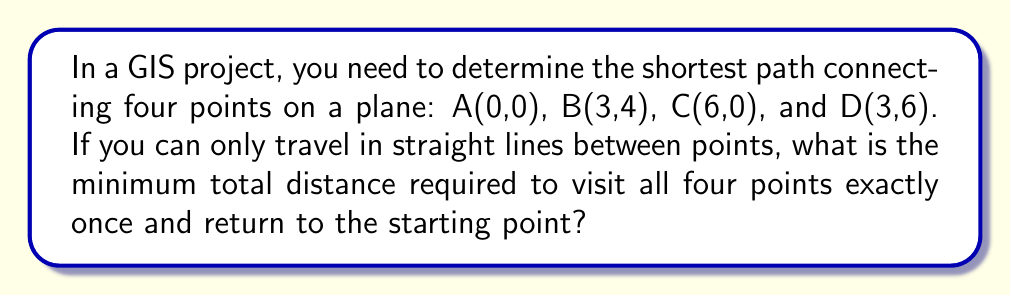Teach me how to tackle this problem. To solve this problem, we need to consider all possible paths and calculate their lengths. The approach is as follows:

1) First, list all possible paths:
   ABCDA, ABDCA, ACBDA, ACDBA, ADBCA, ADCBA

2) For each path, calculate the total distance using the distance formula:
   $d = \sqrt{(x_2-x_1)^2 + (y_2-y_1)^2}$

3) Let's calculate the distances between each pair of points:
   AB = $\sqrt{3^2 + 4^2} = 5$
   AC = $\sqrt{6^2 + 0^2} = 6$
   AD = $\sqrt{3^2 + 6^2} = 3\sqrt{5}$
   BC = $\sqrt{3^2 + (-4)^2} = 5$
   BD = $\sqrt{0^2 + 2^2} = 2$
   CD = $\sqrt{3^2 + 6^2} = 3\sqrt{5}$

4) Now, calculate the total distance for each path:
   ABCDA: $5 + 5 + 3\sqrt{5} + 6 = 16 + 3\sqrt{5}$
   ABDCA: $5 + 2 + 3\sqrt{5} + 6 = 13 + 3\sqrt{5}$
   ACBDA: $6 + 5 + 2 + 3\sqrt{5} = 13 + 3\sqrt{5}$
   ACDBA: $6 + 3\sqrt{5} + 2 + 5 = 13 + 3\sqrt{5}$
   ADBCA: $3\sqrt{5} + 2 + 5 + 6 = 13 + 3\sqrt{5}$
   ADCBA: $3\sqrt{5} + 3\sqrt{5} + 5 + 6 = 11 + 6\sqrt{5}$

5) The shortest path is ADCBA with a total distance of $11 + 6\sqrt{5}$.

[asy]
unitsize(1cm);
pair A=(0,0), B=(3,4), C=(6,0), D=(3,6);
draw(A--D--C--B--A,red);
dot("A",A,SW);
dot("B",B,SE);
dot("C",C,SE);
dot("D",D,N);
[/asy]
Answer: $11 + 6\sqrt{5}$ 